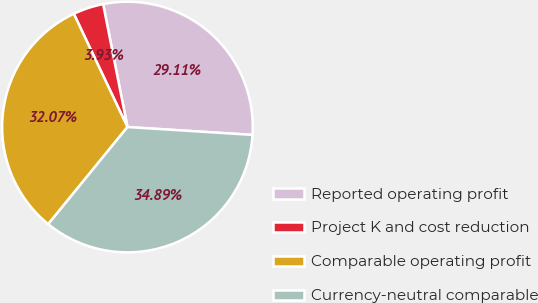<chart> <loc_0><loc_0><loc_500><loc_500><pie_chart><fcel>Reported operating profit<fcel>Project K and cost reduction<fcel>Comparable operating profit<fcel>Currency-neutral comparable<nl><fcel>29.11%<fcel>3.93%<fcel>32.07%<fcel>34.89%<nl></chart> 